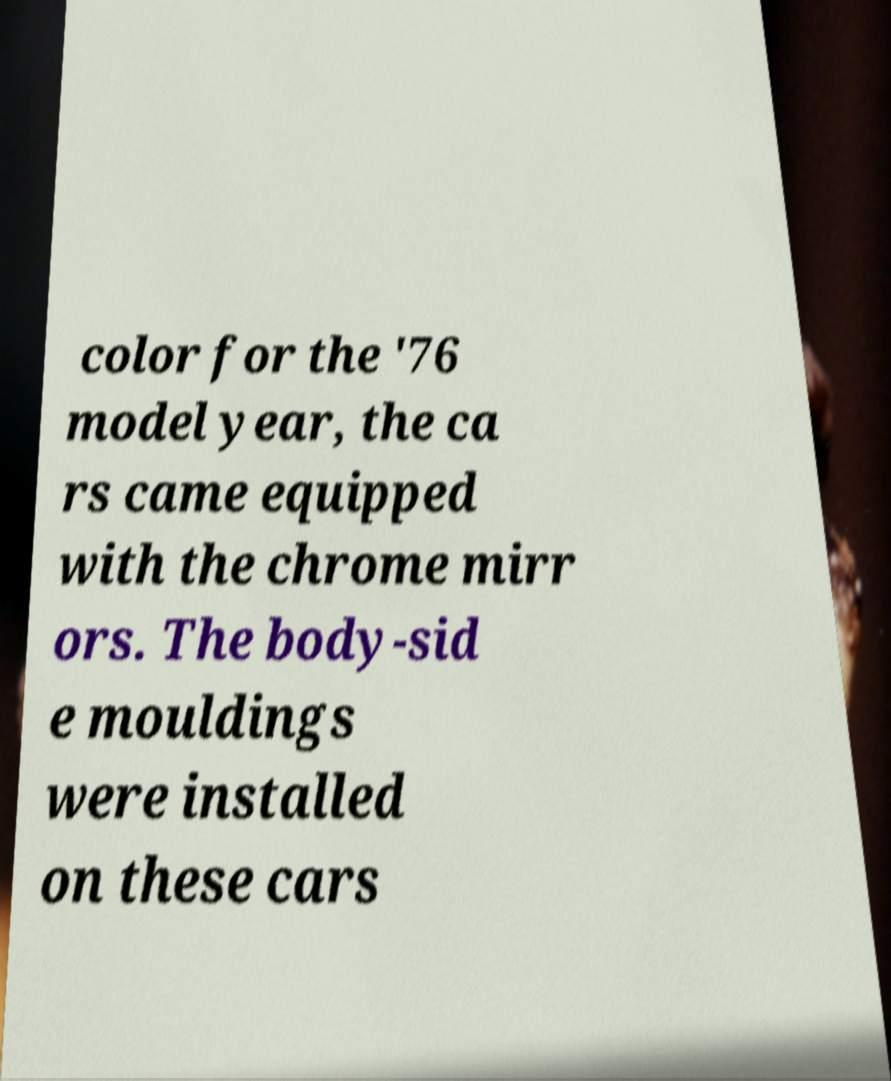Please identify and transcribe the text found in this image. color for the '76 model year, the ca rs came equipped with the chrome mirr ors. The body-sid e mouldings were installed on these cars 